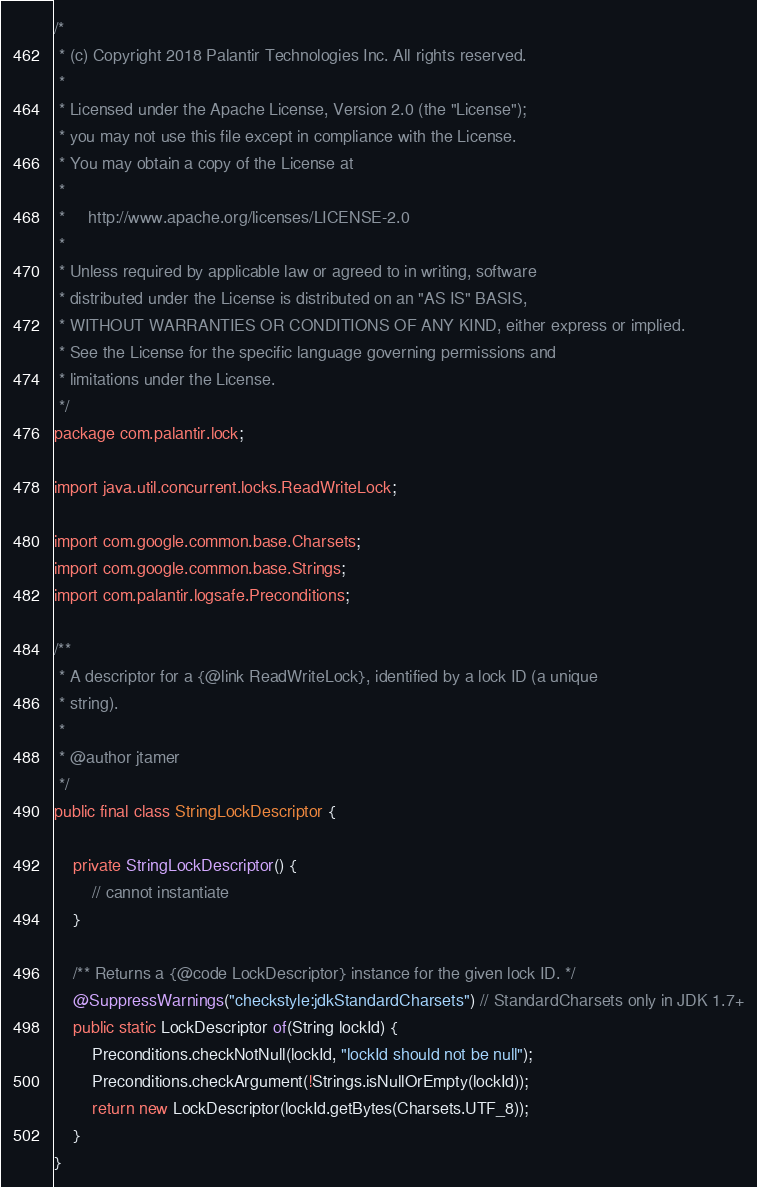<code> <loc_0><loc_0><loc_500><loc_500><_Java_>/*
 * (c) Copyright 2018 Palantir Technologies Inc. All rights reserved.
 *
 * Licensed under the Apache License, Version 2.0 (the "License");
 * you may not use this file except in compliance with the License.
 * You may obtain a copy of the License at
 *
 *     http://www.apache.org/licenses/LICENSE-2.0
 *
 * Unless required by applicable law or agreed to in writing, software
 * distributed under the License is distributed on an "AS IS" BASIS,
 * WITHOUT WARRANTIES OR CONDITIONS OF ANY KIND, either express or implied.
 * See the License for the specific language governing permissions and
 * limitations under the License.
 */
package com.palantir.lock;

import java.util.concurrent.locks.ReadWriteLock;

import com.google.common.base.Charsets;
import com.google.common.base.Strings;
import com.palantir.logsafe.Preconditions;

/**
 * A descriptor for a {@link ReadWriteLock}, identified by a lock ID (a unique
 * string).
 *
 * @author jtamer
 */
public final class StringLockDescriptor {

    private StringLockDescriptor() {
        // cannot instantiate
    }

    /** Returns a {@code LockDescriptor} instance for the given lock ID. */
    @SuppressWarnings("checkstyle:jdkStandardCharsets") // StandardCharsets only in JDK 1.7+
    public static LockDescriptor of(String lockId) {
        Preconditions.checkNotNull(lockId, "lockId should not be null");
        Preconditions.checkArgument(!Strings.isNullOrEmpty(lockId));
        return new LockDescriptor(lockId.getBytes(Charsets.UTF_8));
    }
}
</code> 